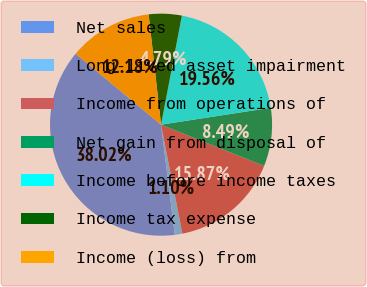Convert chart to OTSL. <chart><loc_0><loc_0><loc_500><loc_500><pie_chart><fcel>Net sales<fcel>Long-lived asset impairment<fcel>Income from operations of<fcel>Net gain from disposal of<fcel>Income before income taxes<fcel>Income tax expense<fcel>Income (loss) from<nl><fcel>38.02%<fcel>1.1%<fcel>15.87%<fcel>8.49%<fcel>19.56%<fcel>4.79%<fcel>12.18%<nl></chart> 